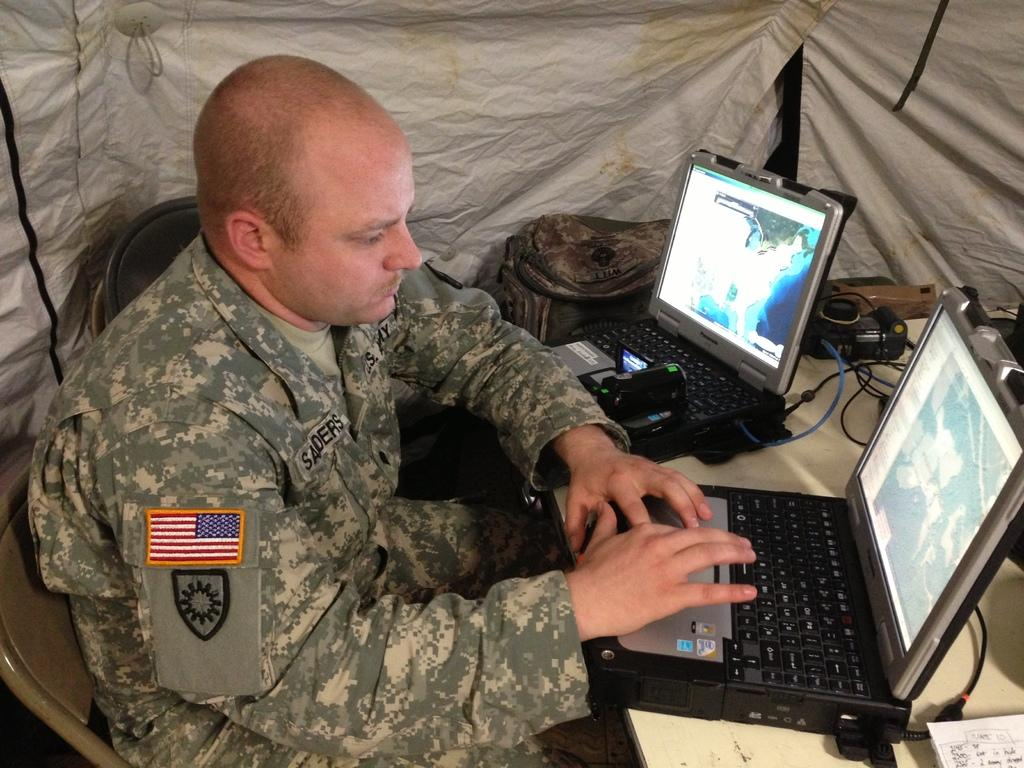<image>
Provide a brief description of the given image. A U.S. Army soldier sits at a table with two Panasonic laptops in front of him. 